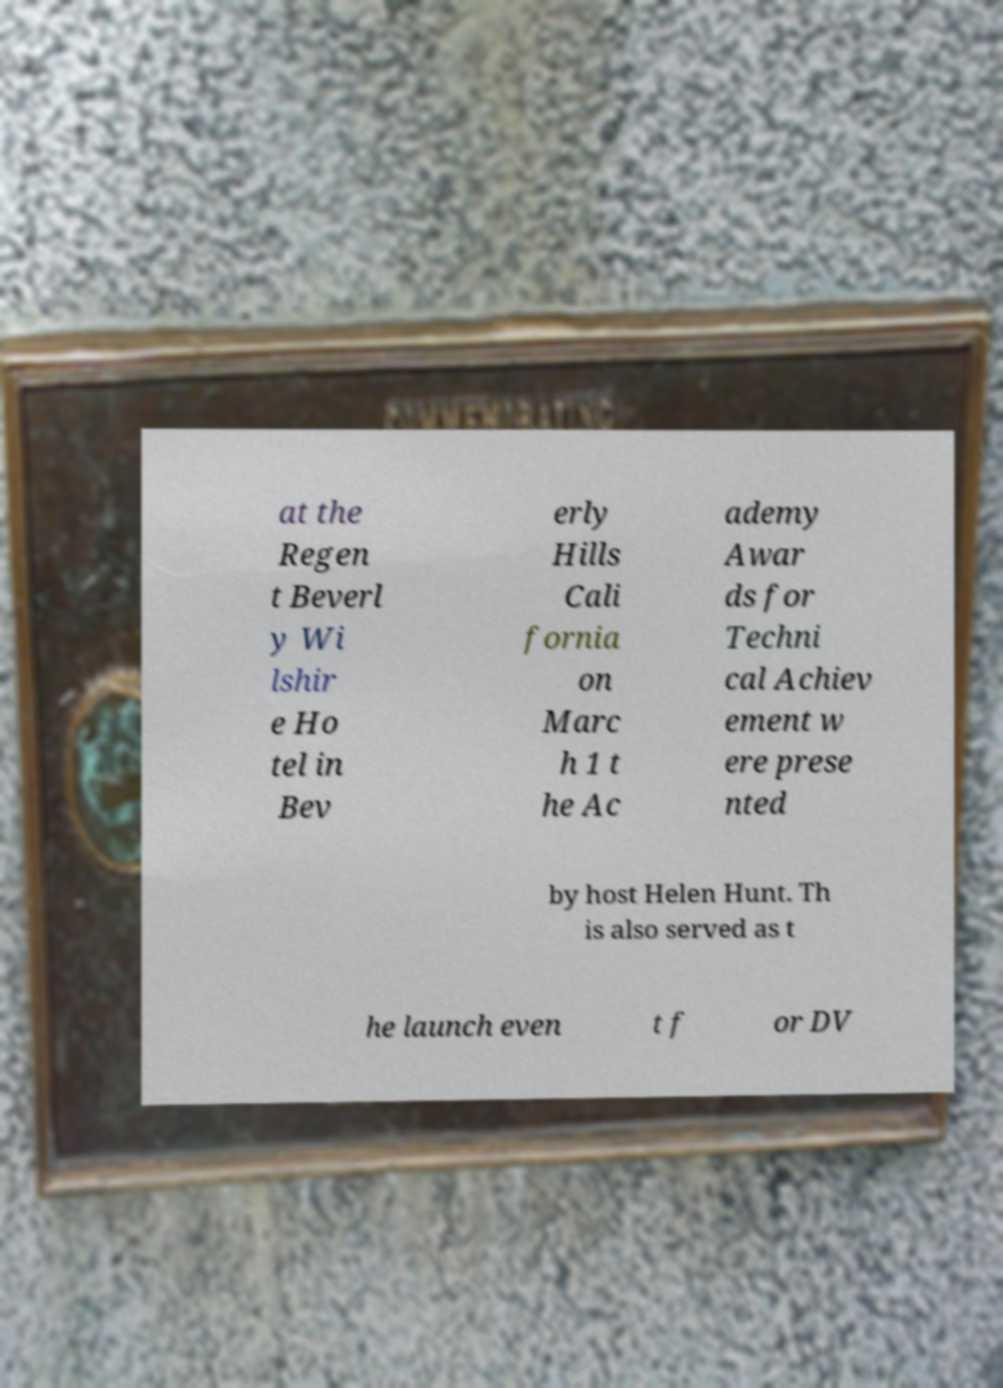I need the written content from this picture converted into text. Can you do that? at the Regen t Beverl y Wi lshir e Ho tel in Bev erly Hills Cali fornia on Marc h 1 t he Ac ademy Awar ds for Techni cal Achiev ement w ere prese nted by host Helen Hunt. Th is also served as t he launch even t f or DV 